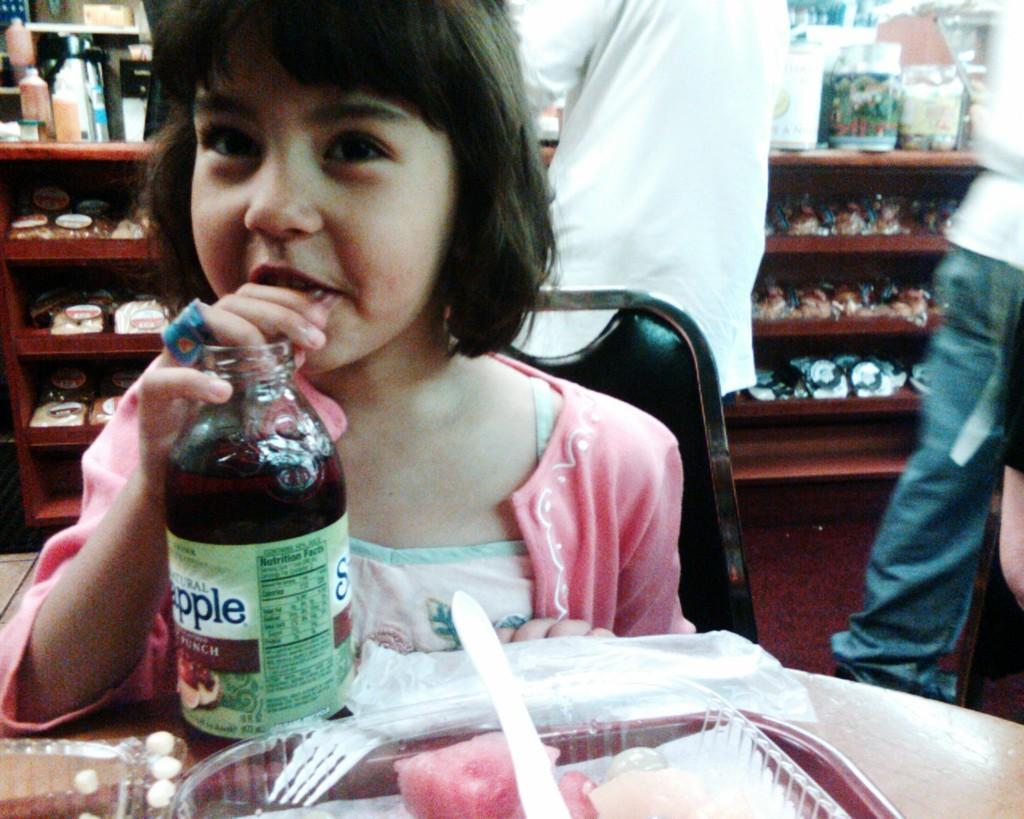How would you summarize this image in a sentence or two? In the foreground, a girl is sitting on the chair in front of the table on which tray, spoon, fruits etc., kept. And she is drinking apple juice from the bottle. Behind that two person are there, who are half visible. In the background middle, shelf is there in which cups, toys, bottles, cosmetics etc., kept. This image is taken inside a shop. 